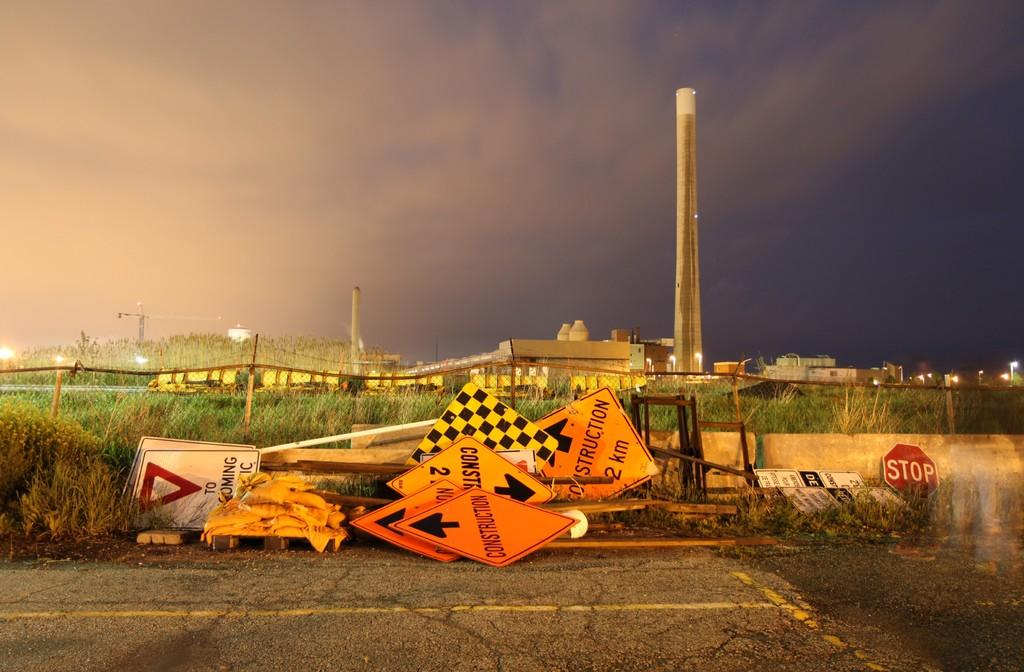Provide a one-sentence caption for the provided image. many yield and construction signs are piled along side the road. 